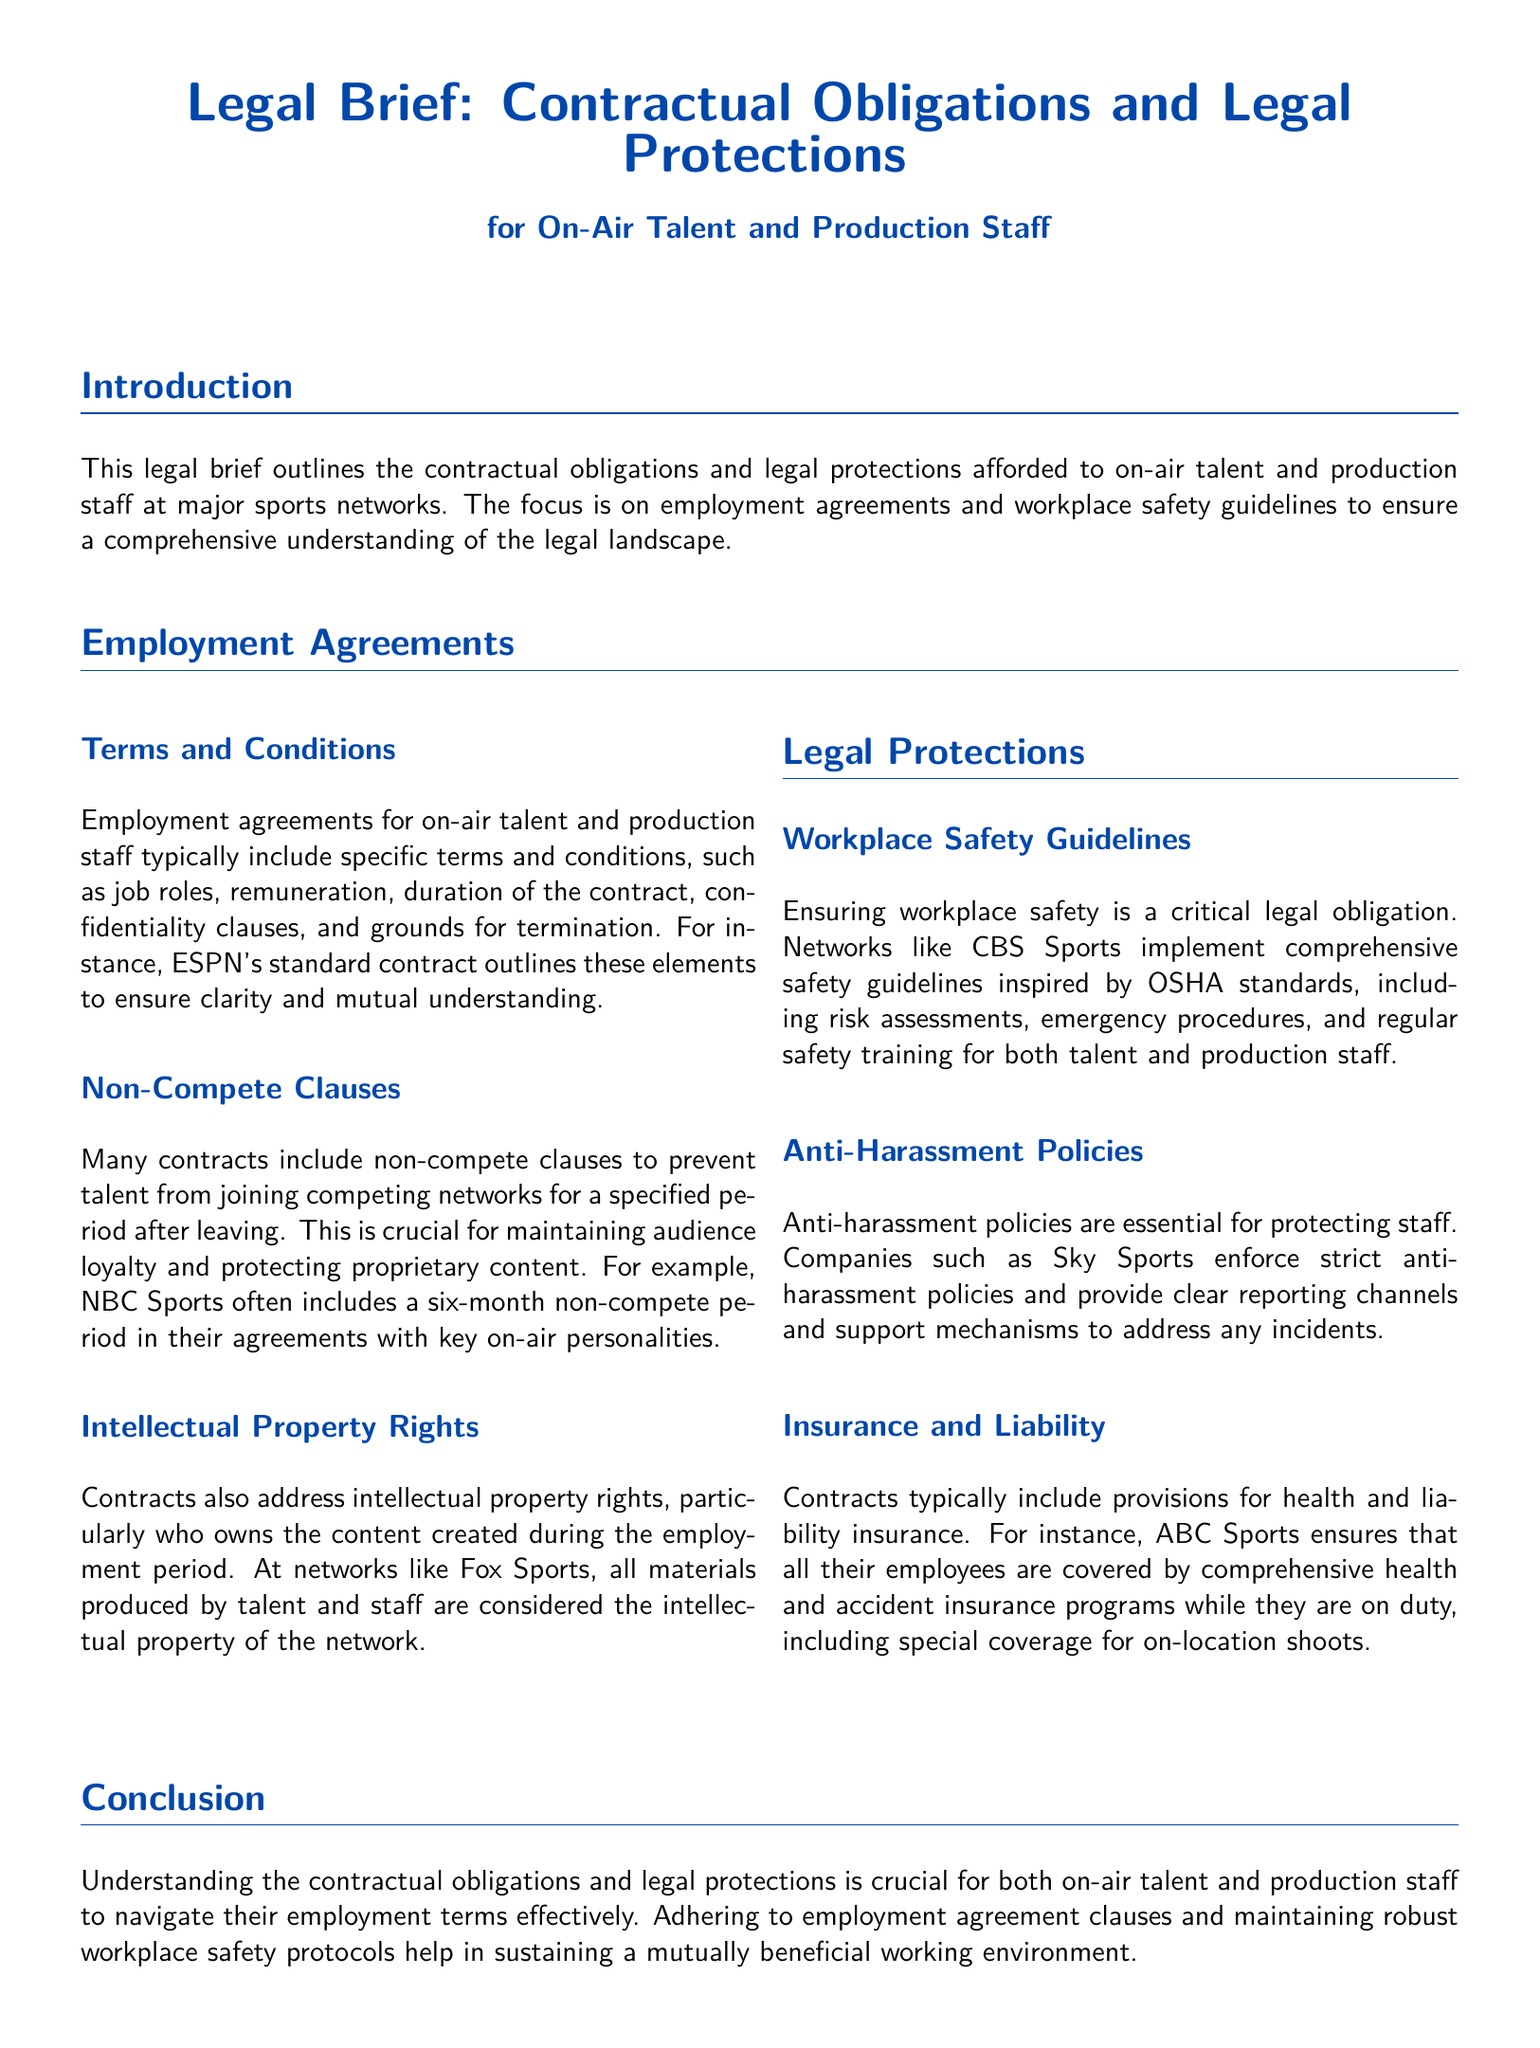What is the purpose of the legal brief? The legal brief outlines the contractual obligations and legal protections for on-air talent and production staff.
Answer: contractual obligations and legal protections What elements are typically included in employment agreements? Employment agreements typically include job roles, remuneration, duration of the contract, confidentiality clauses, and grounds for termination.
Answer: job roles, remuneration, duration of the contract, confidentiality clauses, grounds for termination What is the duration of the non-compete clause mentioned for NBC Sports? NBC Sports includes a six-month non-compete period in their agreements.
Answer: six months Which network considers all materials produced by talent as intellectual property? Fox Sports considers all materials produced by talent and staff as the intellectual property of the network.
Answer: Fox Sports What guidelines do CBS Sports implement for workplace safety? CBS Sports implements comprehensive safety guidelines inspired by OSHA standards.
Answer: OSHA standards Which type of insurance is commonly included in contracts for staff? Contracts typically include provisions for health and liability insurance.
Answer: health and liability insurance What do anti-harassment policies provide for staff? Anti-harassment policies provide clear reporting channels and support mechanisms to address any incidents.
Answer: clear reporting channels and support mechanisms What is the primary focus of the introduction in the document? The introduction focuses on employment agreements and workplace safety guidelines.
Answer: employment agreements and workplace safety guidelines 